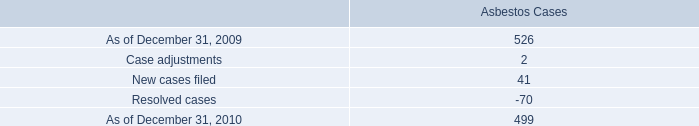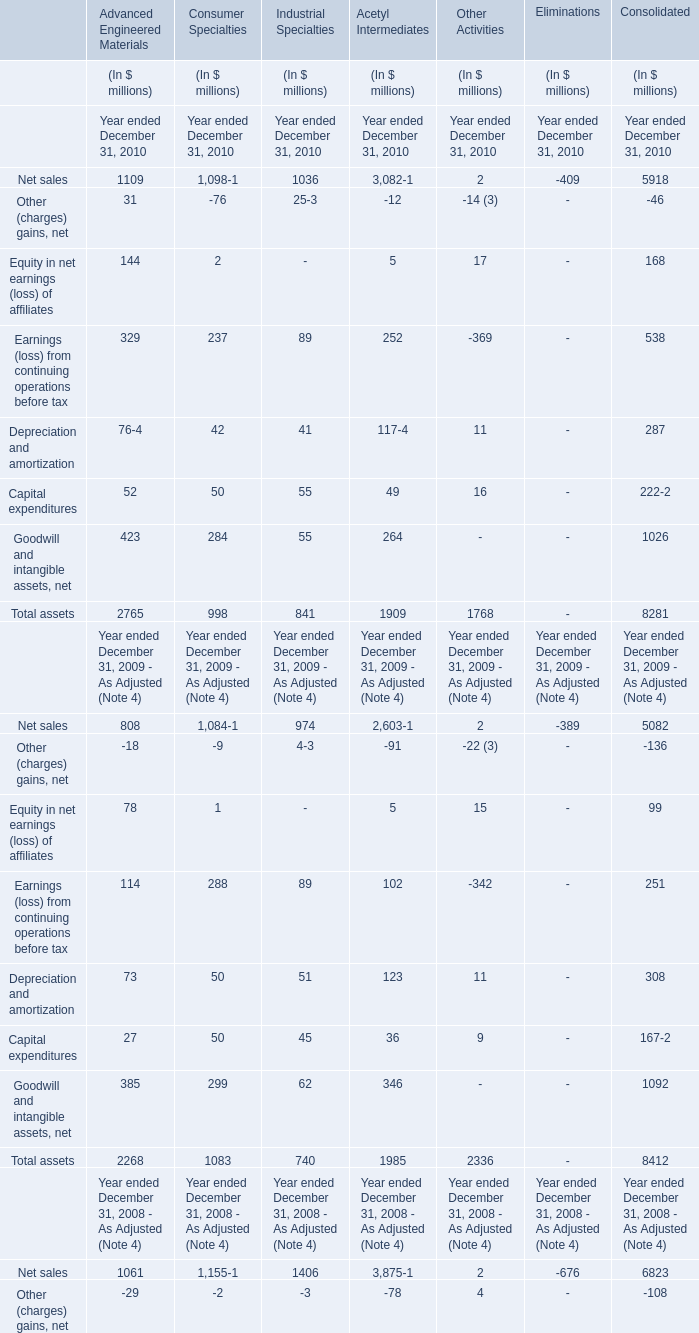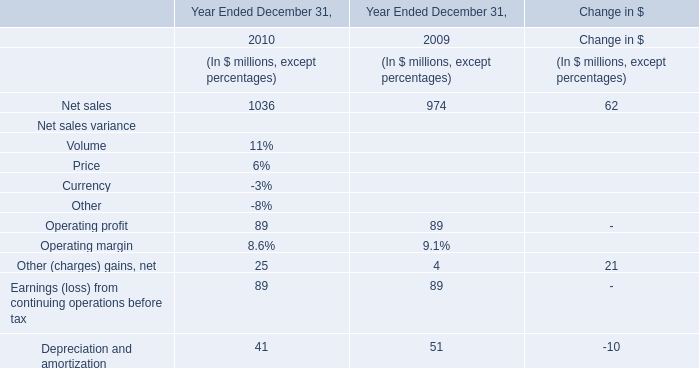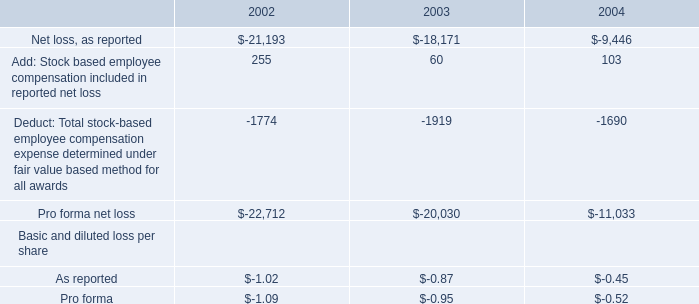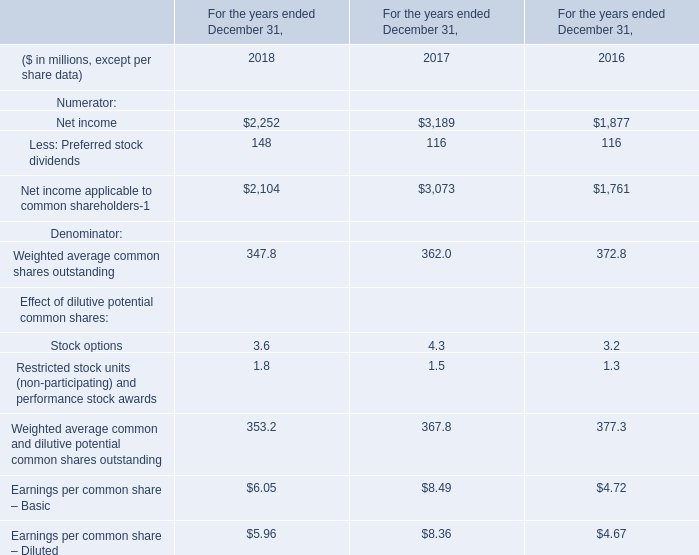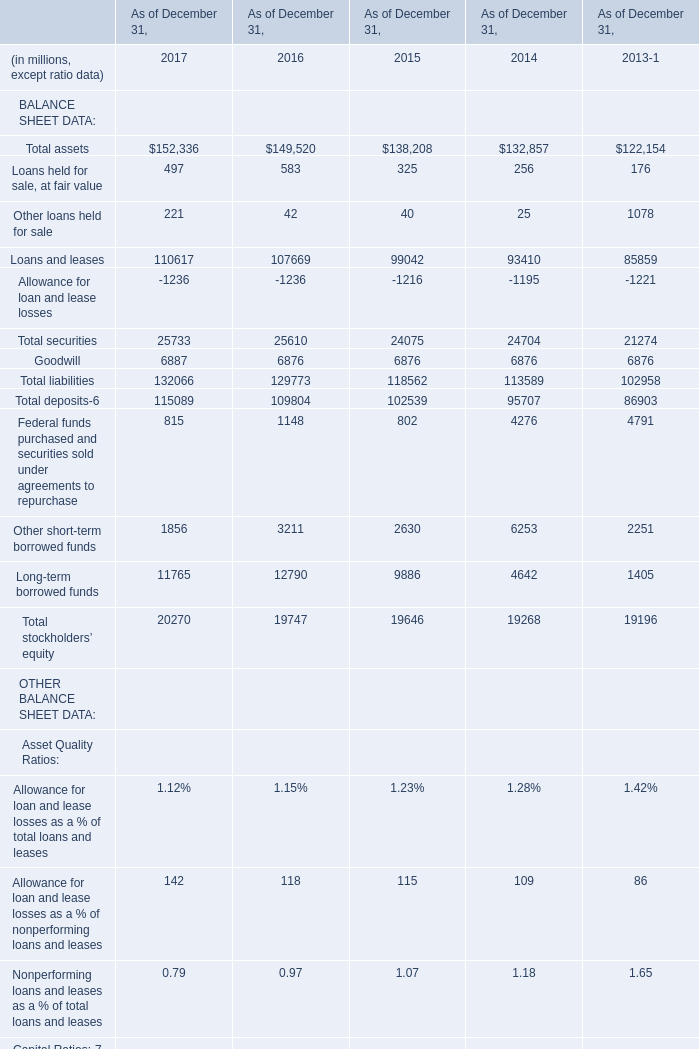in 2010 what was the percentage decline in the asbestos cases from 2009 
Computations: ((499 - 526) / 526)
Answer: -0.05133. 